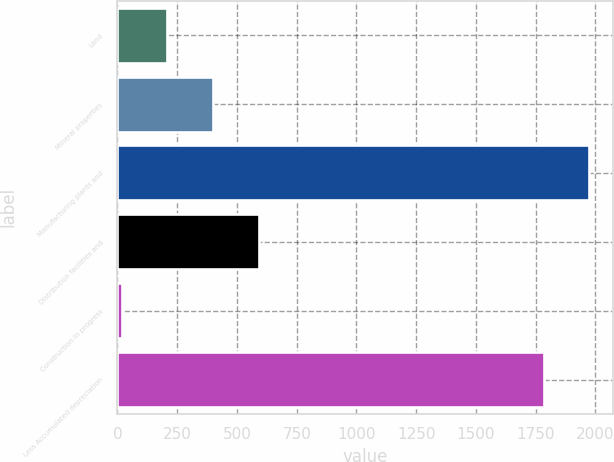<chart> <loc_0><loc_0><loc_500><loc_500><bar_chart><fcel>Land<fcel>Mineral properties<fcel>Manufacturing plants and<fcel>Distribution facilities and<fcel>Construction in progress<fcel>Less Accumulated depreciation<nl><fcel>209.06<fcel>399.92<fcel>1973.96<fcel>590.78<fcel>18.2<fcel>1783.1<nl></chart> 